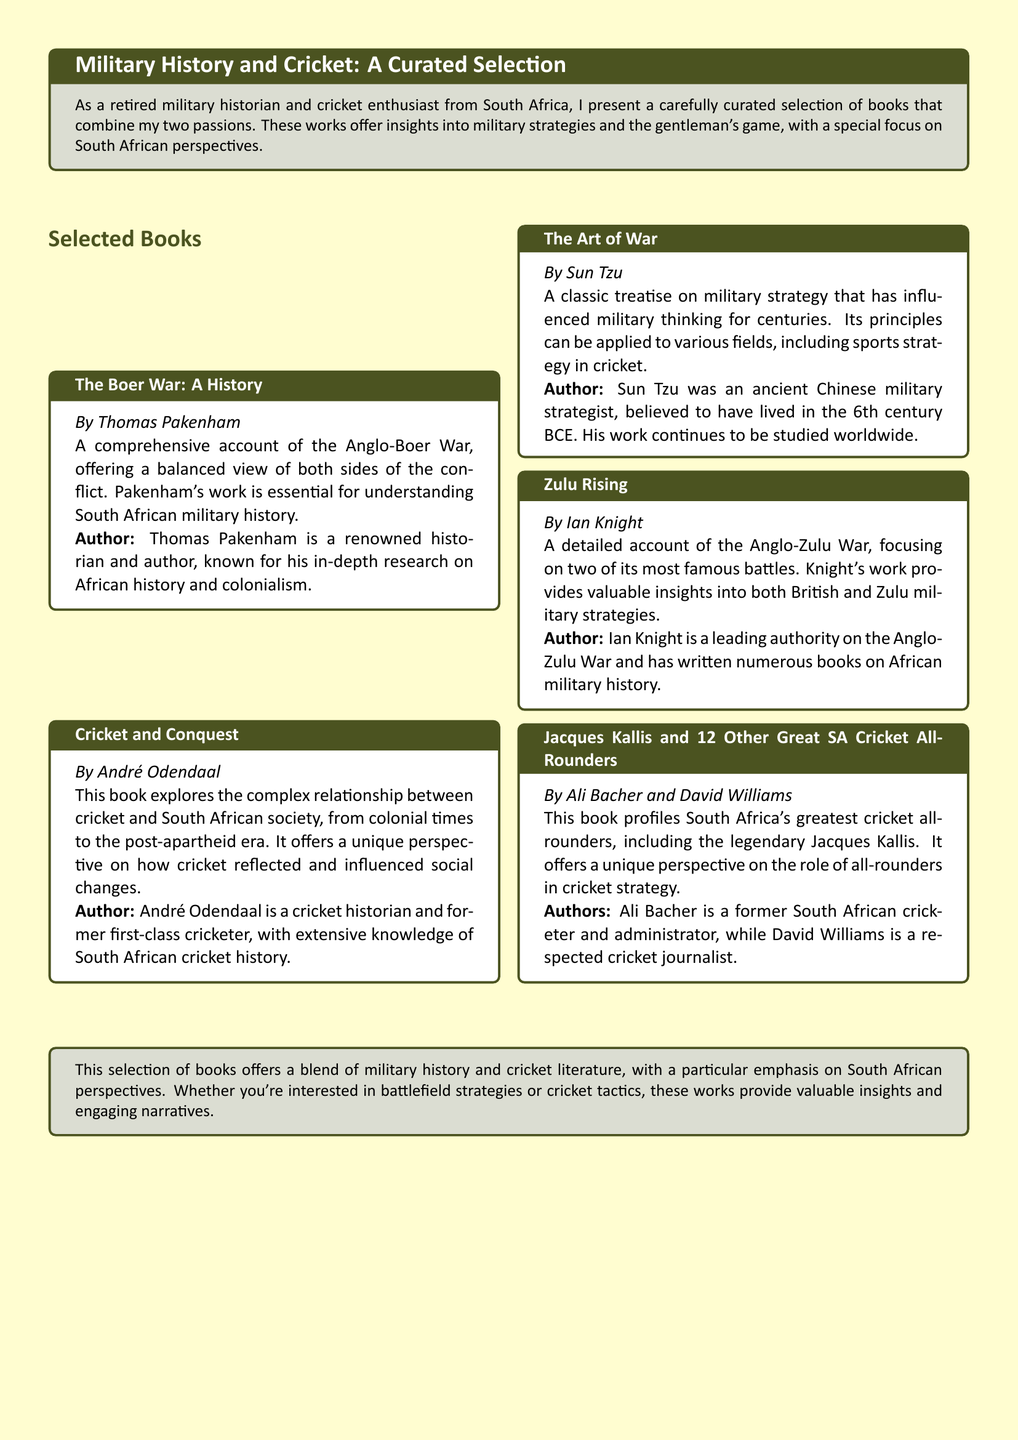What is the first book listed in the selection? The first book listed is provided under the "Selected Books" section of the document.
Answer: The Boer War: A History Who is the author of "Cricket and Conquest"? The author is mentioned directly under the book title in the document.
Answer: André Odendaal Which battle does "Zulu Rising" focus on? The title refers to the Anglo-Zulu War, with emphasis on battle details in the text.
Answer: Anglo-Zulu War What is the main topic of "The Art of War"? The book's overview specifies it discusses military strategy.
Answer: Military strategy How many authors contributed to the book "Jacques Kallis and 12 Other Great SA Cricket All-Rounders"? The information regarding the number of authors can be derived from the author section of the book in the document.
Answer: Two 